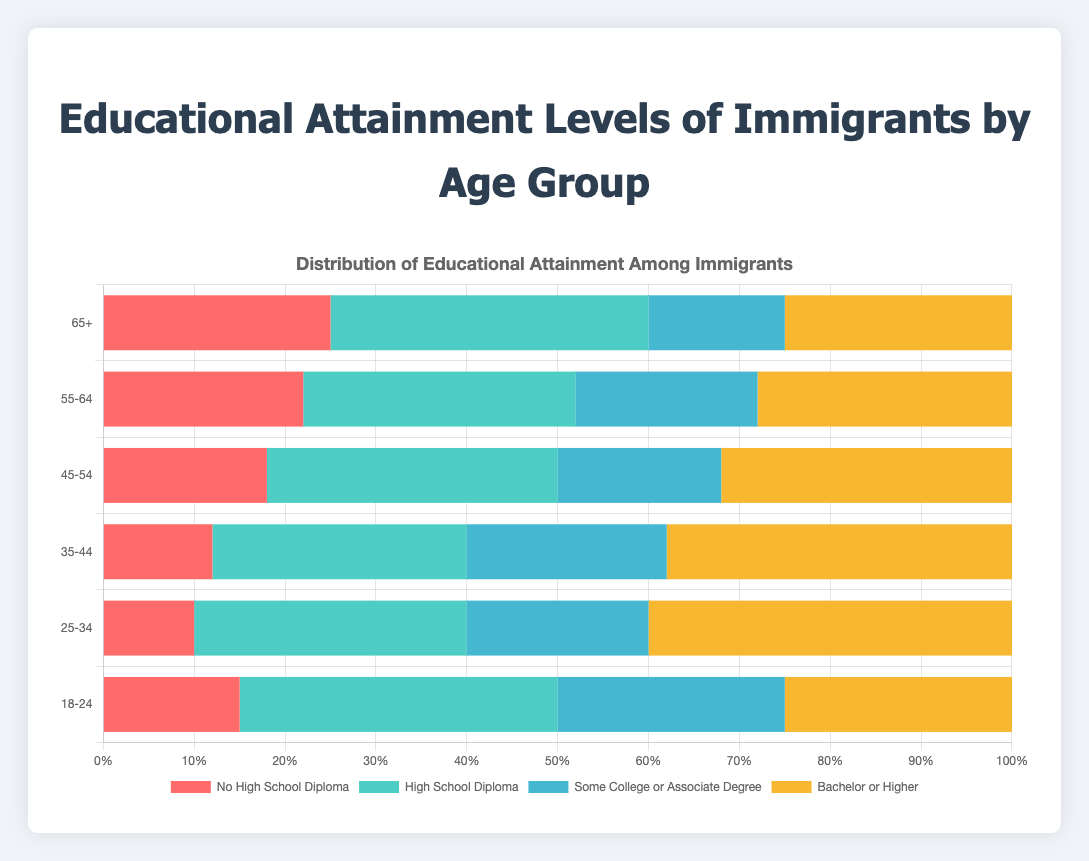What is the highest percentage of immigrants with a Bachelor or higher degree and in which age group? Look for the bar segment representing "Bachelor or Higher" and compare the lengths across all age groups. The longest bar indicates the highest percentage, which is in the "25-34" age group with 40%.
Answer: 25-34 Which age group has the lowest percentage of immigrants with no high school diploma? Compare the lengths of the "No High School Diploma" bar segments across all age groups. The shortest bar is in the "25-34" age group with 10%.
Answer: 25-34 What is the combined percentage of immigrants aged 45-54 with either a high school diploma or some college/associate degree? Add the percentages of "High School Diploma" (32) and "Some College or Associate Degree" (18) for the 45-54 age group. 32 + 18 = 50%.
Answer: 50% Compare the percentage of immigrants aged 35-44 with some college/associate degree to those aged 55-64 with the same level of education. Which age group has a higher percentage and by how much? Subtract the percentage of "Some College or Associate Degree" in the 55-64 age group (20%) from that in the 35-44 age group (22%). 22 - 20 = 2%. The 35-44 age group has a higher percentage by 2%.
Answer: 35-44 by 2% Are there any age groups where the percentage of immigrants with a high school diploma is equal to the percentage with no high school diploma? Compare the "High School Diploma" and "No High School Diploma" percentages for each age group. No age group has equal percentages for these two categories.
Answer: No In the 18-24 age group, what is the percentage difference between those with a high school diploma and those with some college/associate degree? Subtract the percentage of "Some College or Associate Degree" (25) from the percentage of "High School Diploma" (35) in the 18-24 age group. 35 - 25 = 10%.
Answer: 10% In which age group is the distribution of educational attainment levels most balanced? Evaluate the differences in bar lengths for each educational category across age groups. The "18-24" age group has relatively similar bar lengths, indicating a more balanced distribution.
Answer: 18-24 What is the total percentage of immigrants aged 65+ with at least some college education? Add the percentages of "Some College or Associate Degree" (15) and "Bachelor or Higher" (25) for the 65+ age group. 15 + 25 = 40%.
Answer: 40% Which age group has the smallest gap between the highest and lowest education levels? For each age group, find the difference between the highest percentage ("High School Diploma" or "Bachelor or Higher") and the lowest percentage ("No High School Diploma"). The "25-34" age group has a smallest gap between 10% (No High School Diploma) and 30% (High School Diploma), which is 20%.
Answer: 25-34 